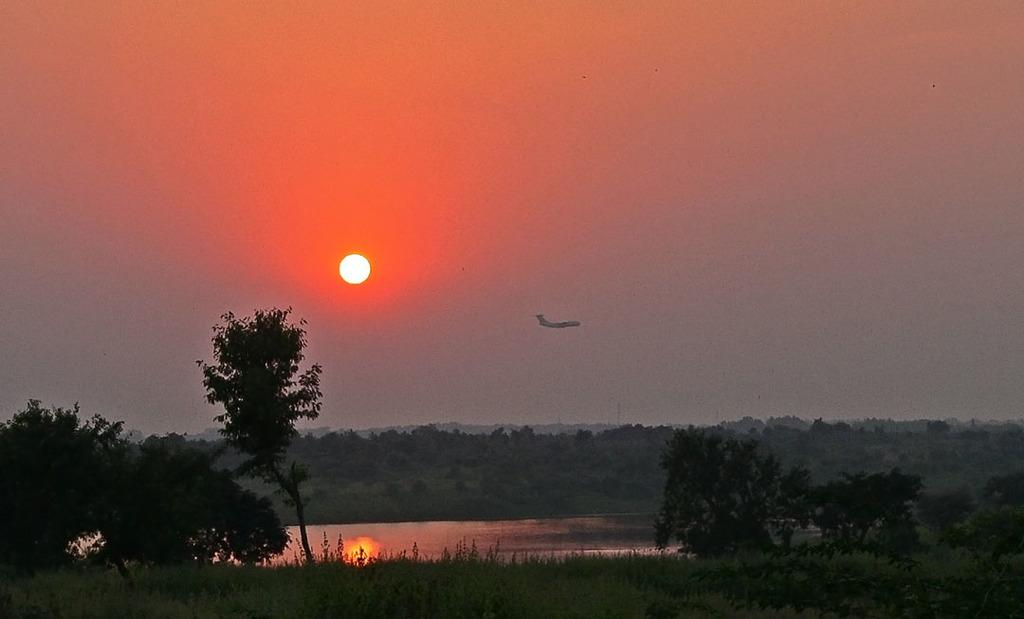What is flying in the air in the image? There is an airplane flying in the air in the image. What body of water is present in the image? There is a lake in the image. What is covering the surface of the lake? The lake is covered with plants. What type of vegetation is present around the lake? Trees are present around the lake. What is visible in the sky in the image? The sky is visible in the image, and the sun is visible in the sky. How many bubbles are floating on the lake in the image? There are no bubbles present on the lake in the image. What type of spiders can be seen crawling on the trees in the image? There are no spiders visible on the trees in the image. 